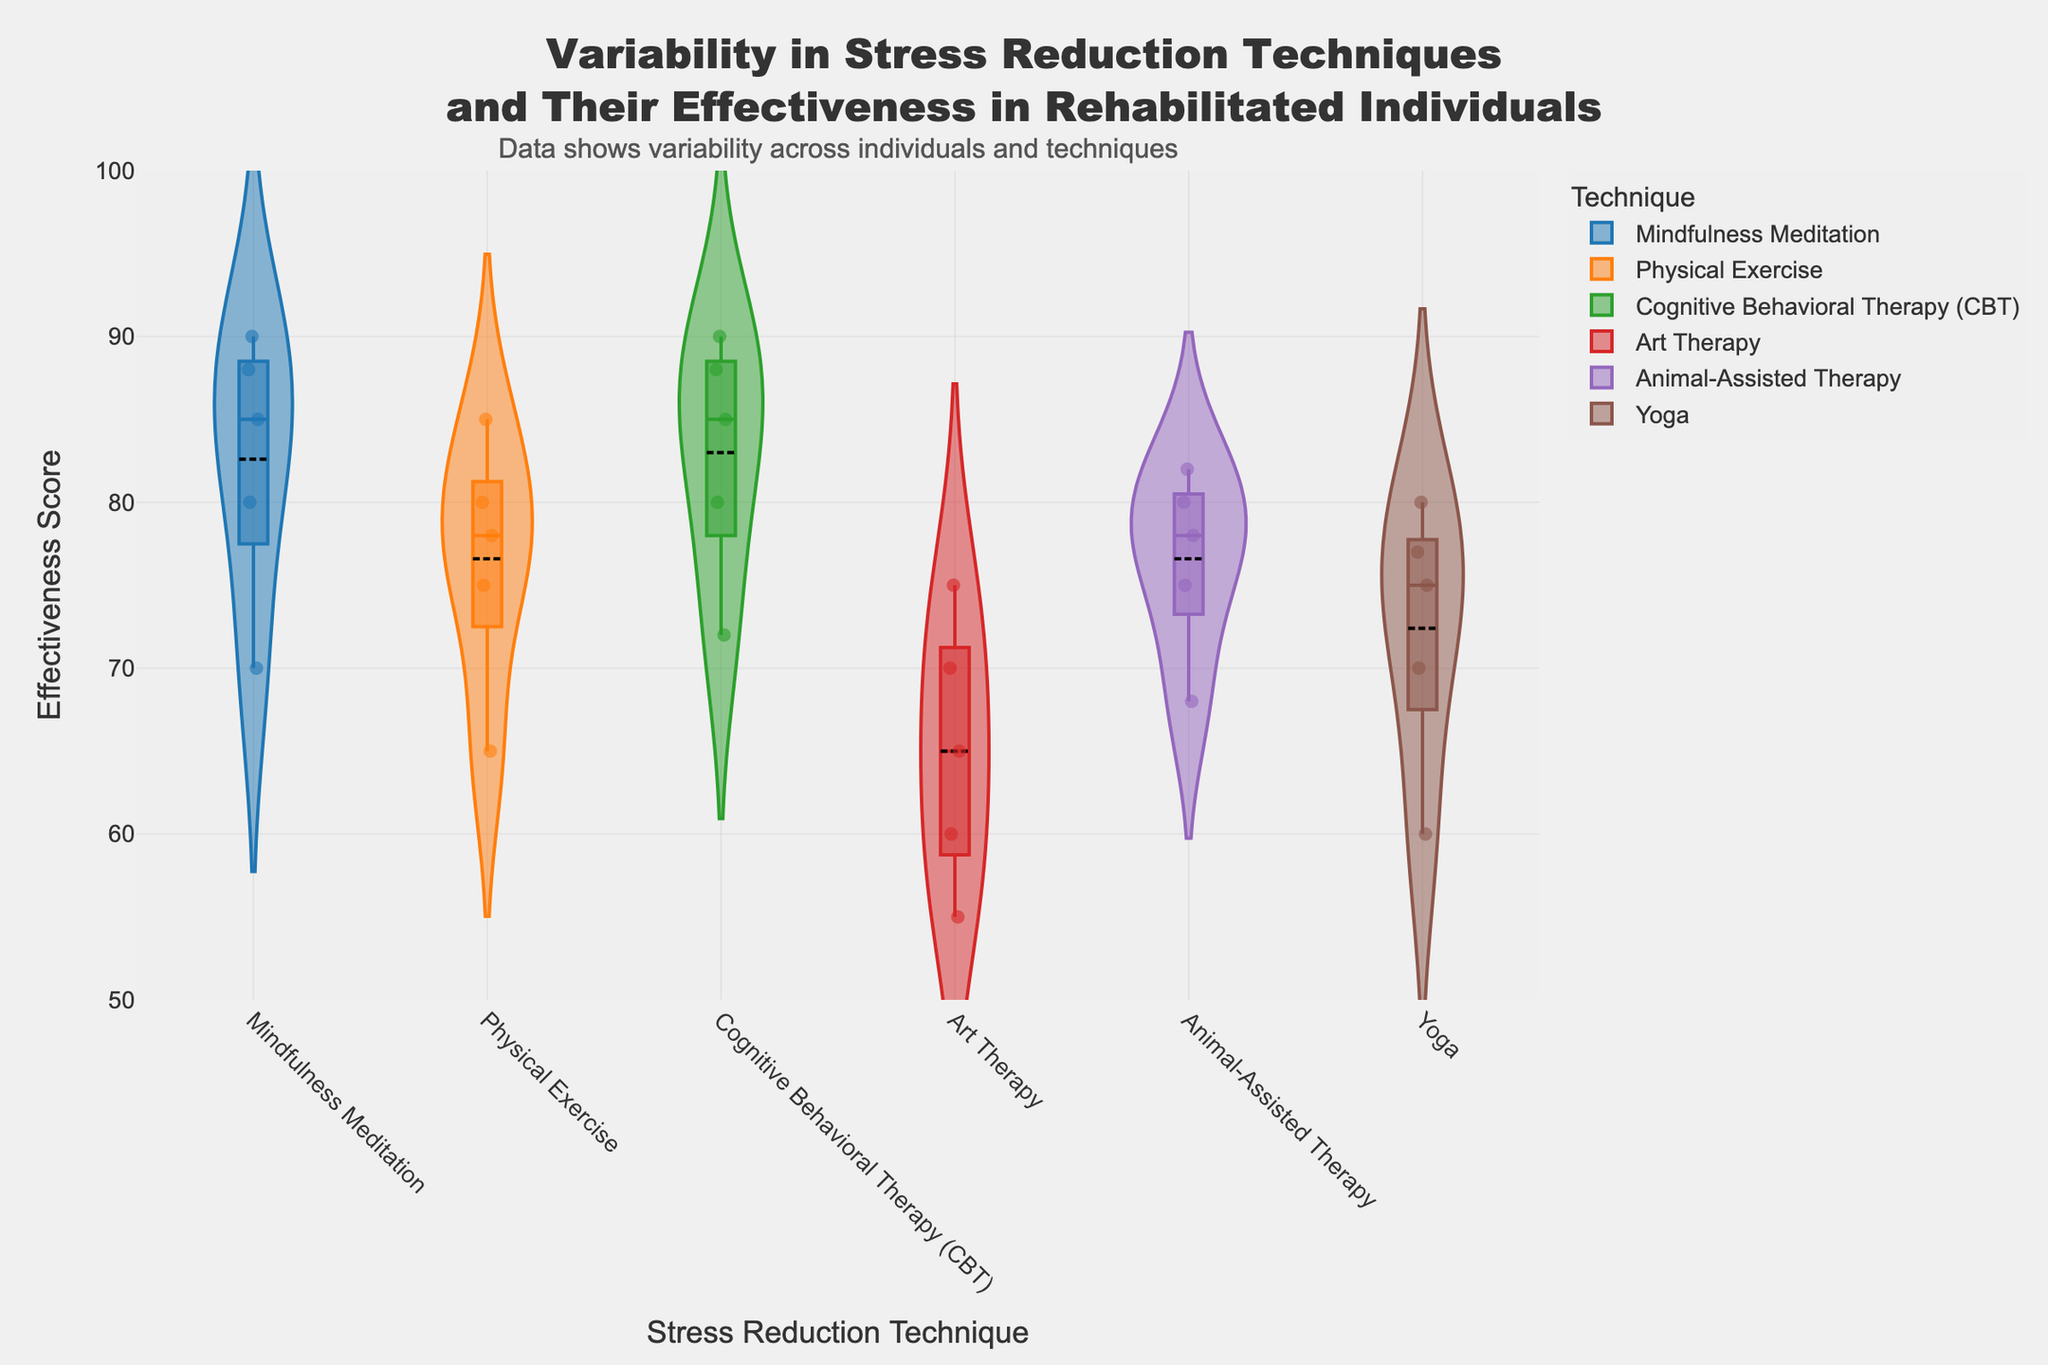What is the title of the plot? The title is usually placed at the top of the plot. In this figure, the title is "Variability in Stress Reduction Techniques and Their Effectiveness in Rehabilitated Individuals".
Answer: Variability in Stress Reduction Techniques and Their Effectiveness in Rehabilitated Individuals What is the range of the y-axis? The y-axis in this plot is labeled "Effectiveness Score". The range, as indicated by the axis labels, is from 50 to 100.
Answer: 50 to 100 Which stress reduction technique has the highest median effectiveness score? The median effectiveness score for each technique is represented by the black line within each violin plot. By comparing these lines, Cognitive Behavioral Therapy (CBT) has the highest median score.
Answer: Cognitive Behavioral Therapy (CBT) What is the mean effectiveness score of Physical Exercise? The mean effectiveness score is represented by the central dashed line within each violin plot. For Physical Exercise, this line is around 76.6.
Answer: 76.6 Which individual shows the highest effectiveness score in Yoga? By looking at the jittered points within the violin for Yoga, the highest point is around Michael Green's score of 77.
Answer: Michael Green What is the effectiveness score difference between Mindfulness Meditation and Art Therapy? The median effectiveness scores for Mindfulness Meditation and Art Therapy are around 83 and 65 respectively. The difference is 83 - 65 = 18.
Answer: 18 Which technique shows the highest variability in effectiveness scores? The variability in effectiveness scores can be inferred from the spread of the violin plot. Art Therapy has the widest spread, indicating the highest variability.
Answer: Art Therapy Compare the mean effectiveness scores of Animal-Assisted Therapy and Yoga. Which one is higher? The mean effectiveness scores are represented by the dashed lines within each violin plot. Animal-Assisted Therapy's mean is approximately 76.6, while Yoga's mean is about 72. The mean for Animal-Assisted Therapy is higher.
Answer: Animal-Assisted Therapy How many data points are there in the Mindfulness Meditation technique? Each data point within the violin plot is represented by a jittered point. For Mindfulness Meditation, count the number of points; there are 5 data points.
Answer: 5 